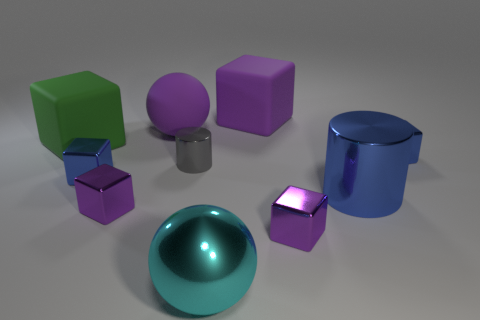Subtract all yellow spheres. How many purple blocks are left? 3 Subtract all blue cubes. How many cubes are left? 4 Subtract 2 cubes. How many cubes are left? 4 Subtract all purple matte cubes. How many cubes are left? 5 Subtract all red cubes. Subtract all green cylinders. How many cubes are left? 6 Subtract all cylinders. How many objects are left? 8 Subtract all blue blocks. Subtract all cyan metal objects. How many objects are left? 7 Add 6 large green rubber objects. How many large green rubber objects are left? 7 Add 7 red rubber objects. How many red rubber objects exist? 7 Subtract 0 purple cylinders. How many objects are left? 10 